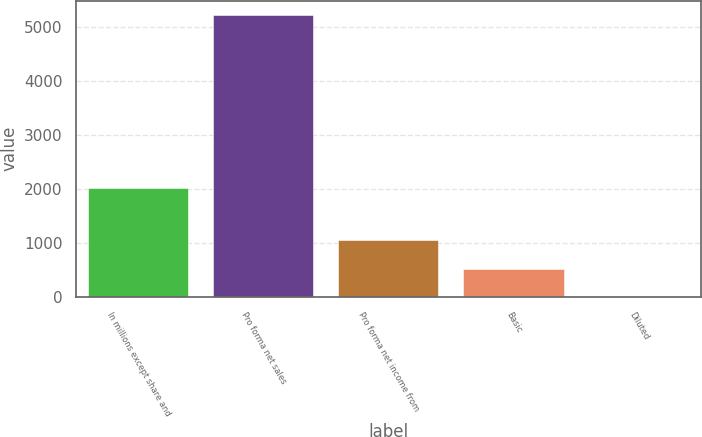Convert chart to OTSL. <chart><loc_0><loc_0><loc_500><loc_500><bar_chart><fcel>In millions except share and<fcel>Pro forma net sales<fcel>Pro forma net income from<fcel>Basic<fcel>Diluted<nl><fcel>2014<fcel>5223.8<fcel>1046.24<fcel>524.05<fcel>1.85<nl></chart> 